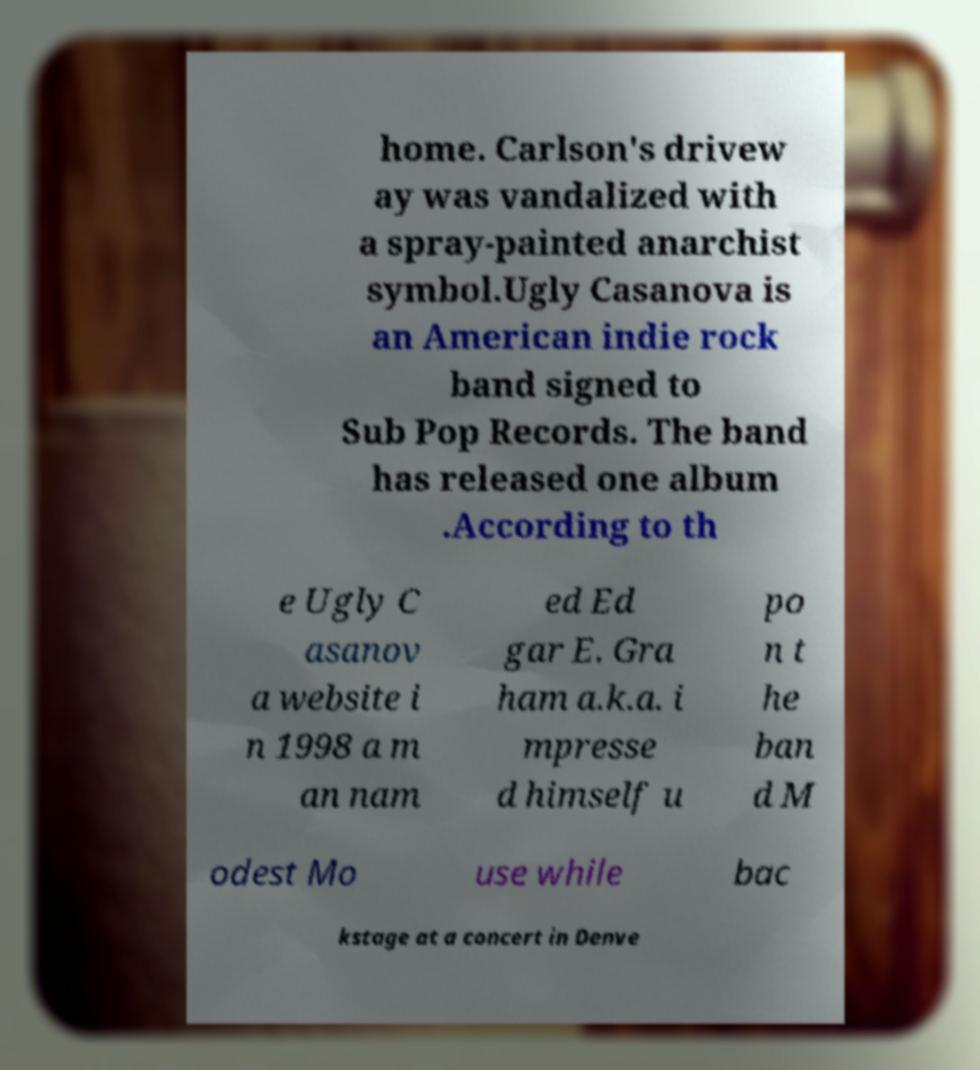What messages or text are displayed in this image? I need them in a readable, typed format. home. Carlson's drivew ay was vandalized with a spray-painted anarchist symbol.Ugly Casanova is an American indie rock band signed to Sub Pop Records. The band has released one album .According to th e Ugly C asanov a website i n 1998 a m an nam ed Ed gar E. Gra ham a.k.a. i mpresse d himself u po n t he ban d M odest Mo use while bac kstage at a concert in Denve 